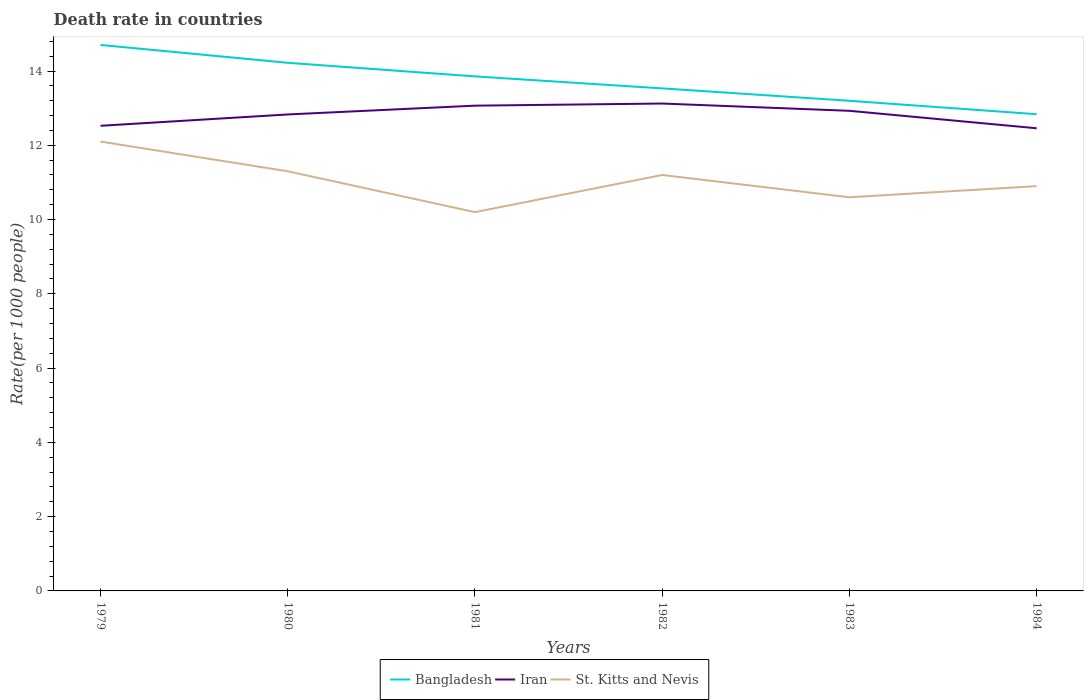How many different coloured lines are there?
Offer a terse response. 3. Across all years, what is the maximum death rate in Bangladesh?
Ensure brevity in your answer.  12.84. What is the total death rate in Bangladesh in the graph?
Provide a short and direct response. 0.66. What is the difference between the highest and the second highest death rate in St. Kitts and Nevis?
Give a very brief answer. 1.9. How many years are there in the graph?
Your response must be concise. 6. What is the difference between two consecutive major ticks on the Y-axis?
Keep it short and to the point. 2. Are the values on the major ticks of Y-axis written in scientific E-notation?
Give a very brief answer. No. Does the graph contain any zero values?
Provide a short and direct response. No. Does the graph contain grids?
Keep it short and to the point. No. Where does the legend appear in the graph?
Offer a terse response. Bottom center. How many legend labels are there?
Your answer should be compact. 3. How are the legend labels stacked?
Your response must be concise. Horizontal. What is the title of the graph?
Provide a short and direct response. Death rate in countries. Does "St. Martin (French part)" appear as one of the legend labels in the graph?
Give a very brief answer. No. What is the label or title of the Y-axis?
Provide a short and direct response. Rate(per 1000 people). What is the Rate(per 1000 people) in Bangladesh in 1979?
Your answer should be very brief. 14.7. What is the Rate(per 1000 people) in Iran in 1979?
Provide a succinct answer. 12.53. What is the Rate(per 1000 people) of St. Kitts and Nevis in 1979?
Your answer should be compact. 12.1. What is the Rate(per 1000 people) of Bangladesh in 1980?
Offer a terse response. 14.22. What is the Rate(per 1000 people) in Iran in 1980?
Keep it short and to the point. 12.83. What is the Rate(per 1000 people) of St. Kitts and Nevis in 1980?
Offer a terse response. 11.3. What is the Rate(per 1000 people) in Bangladesh in 1981?
Keep it short and to the point. 13.86. What is the Rate(per 1000 people) of Iran in 1981?
Your response must be concise. 13.07. What is the Rate(per 1000 people) in St. Kitts and Nevis in 1981?
Provide a succinct answer. 10.2. What is the Rate(per 1000 people) in Bangladesh in 1982?
Provide a succinct answer. 13.53. What is the Rate(per 1000 people) of Iran in 1982?
Give a very brief answer. 13.12. What is the Rate(per 1000 people) of St. Kitts and Nevis in 1982?
Keep it short and to the point. 11.2. What is the Rate(per 1000 people) in Bangladesh in 1983?
Your answer should be compact. 13.2. What is the Rate(per 1000 people) in Iran in 1983?
Keep it short and to the point. 12.93. What is the Rate(per 1000 people) of St. Kitts and Nevis in 1983?
Give a very brief answer. 10.6. What is the Rate(per 1000 people) of Bangladesh in 1984?
Provide a succinct answer. 12.84. What is the Rate(per 1000 people) in Iran in 1984?
Your response must be concise. 12.46. What is the Rate(per 1000 people) in St. Kitts and Nevis in 1984?
Your answer should be very brief. 10.9. Across all years, what is the maximum Rate(per 1000 people) of Bangladesh?
Make the answer very short. 14.7. Across all years, what is the maximum Rate(per 1000 people) in Iran?
Offer a terse response. 13.12. Across all years, what is the minimum Rate(per 1000 people) of Bangladesh?
Provide a short and direct response. 12.84. Across all years, what is the minimum Rate(per 1000 people) in Iran?
Give a very brief answer. 12.46. Across all years, what is the minimum Rate(per 1000 people) of St. Kitts and Nevis?
Offer a terse response. 10.2. What is the total Rate(per 1000 people) in Bangladesh in the graph?
Offer a terse response. 82.34. What is the total Rate(per 1000 people) in Iran in the graph?
Make the answer very short. 76.93. What is the total Rate(per 1000 people) of St. Kitts and Nevis in the graph?
Make the answer very short. 66.3. What is the difference between the Rate(per 1000 people) of Bangladesh in 1979 and that in 1980?
Provide a short and direct response. 0.48. What is the difference between the Rate(per 1000 people) in Iran in 1979 and that in 1980?
Give a very brief answer. -0.3. What is the difference between the Rate(per 1000 people) in St. Kitts and Nevis in 1979 and that in 1980?
Ensure brevity in your answer.  0.8. What is the difference between the Rate(per 1000 people) of Bangladesh in 1979 and that in 1981?
Your answer should be compact. 0.85. What is the difference between the Rate(per 1000 people) in Iran in 1979 and that in 1981?
Give a very brief answer. -0.54. What is the difference between the Rate(per 1000 people) in Bangladesh in 1979 and that in 1982?
Your answer should be compact. 1.17. What is the difference between the Rate(per 1000 people) in Iran in 1979 and that in 1982?
Make the answer very short. -0.6. What is the difference between the Rate(per 1000 people) of Bangladesh in 1979 and that in 1983?
Your answer should be compact. 1.5. What is the difference between the Rate(per 1000 people) in Iran in 1979 and that in 1983?
Provide a succinct answer. -0.4. What is the difference between the Rate(per 1000 people) of St. Kitts and Nevis in 1979 and that in 1983?
Offer a terse response. 1.5. What is the difference between the Rate(per 1000 people) of Bangladesh in 1979 and that in 1984?
Give a very brief answer. 1.86. What is the difference between the Rate(per 1000 people) of Iran in 1979 and that in 1984?
Ensure brevity in your answer.  0.07. What is the difference between the Rate(per 1000 people) in St. Kitts and Nevis in 1979 and that in 1984?
Provide a succinct answer. 1.2. What is the difference between the Rate(per 1000 people) of Bangladesh in 1980 and that in 1981?
Your answer should be very brief. 0.37. What is the difference between the Rate(per 1000 people) of Iran in 1980 and that in 1981?
Give a very brief answer. -0.24. What is the difference between the Rate(per 1000 people) in Bangladesh in 1980 and that in 1982?
Offer a very short reply. 0.69. What is the difference between the Rate(per 1000 people) in Iran in 1980 and that in 1982?
Make the answer very short. -0.29. What is the difference between the Rate(per 1000 people) of St. Kitts and Nevis in 1980 and that in 1982?
Your answer should be very brief. 0.1. What is the difference between the Rate(per 1000 people) of Bangladesh in 1980 and that in 1983?
Keep it short and to the point. 1.02. What is the difference between the Rate(per 1000 people) in Iran in 1980 and that in 1983?
Give a very brief answer. -0.1. What is the difference between the Rate(per 1000 people) of Bangladesh in 1980 and that in 1984?
Your response must be concise. 1.38. What is the difference between the Rate(per 1000 people) of Iran in 1980 and that in 1984?
Ensure brevity in your answer.  0.37. What is the difference between the Rate(per 1000 people) of St. Kitts and Nevis in 1980 and that in 1984?
Offer a very short reply. 0.4. What is the difference between the Rate(per 1000 people) of Bangladesh in 1981 and that in 1982?
Ensure brevity in your answer.  0.32. What is the difference between the Rate(per 1000 people) in Iran in 1981 and that in 1982?
Your response must be concise. -0.06. What is the difference between the Rate(per 1000 people) of Bangladesh in 1981 and that in 1983?
Give a very brief answer. 0.66. What is the difference between the Rate(per 1000 people) in Iran in 1981 and that in 1983?
Your answer should be very brief. 0.14. What is the difference between the Rate(per 1000 people) of Bangladesh in 1981 and that in 1984?
Keep it short and to the point. 1.02. What is the difference between the Rate(per 1000 people) in Iran in 1981 and that in 1984?
Ensure brevity in your answer.  0.61. What is the difference between the Rate(per 1000 people) in St. Kitts and Nevis in 1981 and that in 1984?
Give a very brief answer. -0.7. What is the difference between the Rate(per 1000 people) of Bangladesh in 1982 and that in 1983?
Offer a very short reply. 0.33. What is the difference between the Rate(per 1000 people) of Iran in 1982 and that in 1983?
Your answer should be very brief. 0.2. What is the difference between the Rate(per 1000 people) in Bangladesh in 1982 and that in 1984?
Offer a very short reply. 0.69. What is the difference between the Rate(per 1000 people) of Iran in 1982 and that in 1984?
Your response must be concise. 0.67. What is the difference between the Rate(per 1000 people) in St. Kitts and Nevis in 1982 and that in 1984?
Give a very brief answer. 0.3. What is the difference between the Rate(per 1000 people) of Bangladesh in 1983 and that in 1984?
Provide a short and direct response. 0.36. What is the difference between the Rate(per 1000 people) of Iran in 1983 and that in 1984?
Your answer should be very brief. 0.47. What is the difference between the Rate(per 1000 people) of St. Kitts and Nevis in 1983 and that in 1984?
Ensure brevity in your answer.  -0.3. What is the difference between the Rate(per 1000 people) in Bangladesh in 1979 and the Rate(per 1000 people) in Iran in 1980?
Give a very brief answer. 1.87. What is the difference between the Rate(per 1000 people) of Bangladesh in 1979 and the Rate(per 1000 people) of St. Kitts and Nevis in 1980?
Provide a short and direct response. 3.4. What is the difference between the Rate(per 1000 people) in Iran in 1979 and the Rate(per 1000 people) in St. Kitts and Nevis in 1980?
Provide a short and direct response. 1.23. What is the difference between the Rate(per 1000 people) in Bangladesh in 1979 and the Rate(per 1000 people) in Iran in 1981?
Keep it short and to the point. 1.64. What is the difference between the Rate(per 1000 people) in Bangladesh in 1979 and the Rate(per 1000 people) in St. Kitts and Nevis in 1981?
Ensure brevity in your answer.  4.5. What is the difference between the Rate(per 1000 people) of Iran in 1979 and the Rate(per 1000 people) of St. Kitts and Nevis in 1981?
Provide a succinct answer. 2.33. What is the difference between the Rate(per 1000 people) of Bangladesh in 1979 and the Rate(per 1000 people) of Iran in 1982?
Provide a short and direct response. 1.58. What is the difference between the Rate(per 1000 people) in Bangladesh in 1979 and the Rate(per 1000 people) in St. Kitts and Nevis in 1982?
Offer a very short reply. 3.5. What is the difference between the Rate(per 1000 people) in Iran in 1979 and the Rate(per 1000 people) in St. Kitts and Nevis in 1982?
Offer a terse response. 1.32. What is the difference between the Rate(per 1000 people) of Bangladesh in 1979 and the Rate(per 1000 people) of Iran in 1983?
Keep it short and to the point. 1.77. What is the difference between the Rate(per 1000 people) in Bangladesh in 1979 and the Rate(per 1000 people) in St. Kitts and Nevis in 1983?
Offer a terse response. 4.1. What is the difference between the Rate(per 1000 people) of Iran in 1979 and the Rate(per 1000 people) of St. Kitts and Nevis in 1983?
Provide a short and direct response. 1.93. What is the difference between the Rate(per 1000 people) of Bangladesh in 1979 and the Rate(per 1000 people) of Iran in 1984?
Make the answer very short. 2.24. What is the difference between the Rate(per 1000 people) in Bangladesh in 1979 and the Rate(per 1000 people) in St. Kitts and Nevis in 1984?
Keep it short and to the point. 3.8. What is the difference between the Rate(per 1000 people) in Iran in 1979 and the Rate(per 1000 people) in St. Kitts and Nevis in 1984?
Offer a very short reply. 1.62. What is the difference between the Rate(per 1000 people) in Bangladesh in 1980 and the Rate(per 1000 people) in Iran in 1981?
Offer a very short reply. 1.15. What is the difference between the Rate(per 1000 people) of Bangladesh in 1980 and the Rate(per 1000 people) of St. Kitts and Nevis in 1981?
Your answer should be very brief. 4.02. What is the difference between the Rate(per 1000 people) in Iran in 1980 and the Rate(per 1000 people) in St. Kitts and Nevis in 1981?
Your answer should be very brief. 2.63. What is the difference between the Rate(per 1000 people) in Bangladesh in 1980 and the Rate(per 1000 people) in Iran in 1982?
Offer a terse response. 1.1. What is the difference between the Rate(per 1000 people) of Bangladesh in 1980 and the Rate(per 1000 people) of St. Kitts and Nevis in 1982?
Your answer should be very brief. 3.02. What is the difference between the Rate(per 1000 people) of Iran in 1980 and the Rate(per 1000 people) of St. Kitts and Nevis in 1982?
Ensure brevity in your answer.  1.63. What is the difference between the Rate(per 1000 people) of Bangladesh in 1980 and the Rate(per 1000 people) of Iran in 1983?
Offer a very short reply. 1.29. What is the difference between the Rate(per 1000 people) in Bangladesh in 1980 and the Rate(per 1000 people) in St. Kitts and Nevis in 1983?
Give a very brief answer. 3.62. What is the difference between the Rate(per 1000 people) in Iran in 1980 and the Rate(per 1000 people) in St. Kitts and Nevis in 1983?
Ensure brevity in your answer.  2.23. What is the difference between the Rate(per 1000 people) in Bangladesh in 1980 and the Rate(per 1000 people) in Iran in 1984?
Your answer should be very brief. 1.76. What is the difference between the Rate(per 1000 people) in Bangladesh in 1980 and the Rate(per 1000 people) in St. Kitts and Nevis in 1984?
Keep it short and to the point. 3.32. What is the difference between the Rate(per 1000 people) of Iran in 1980 and the Rate(per 1000 people) of St. Kitts and Nevis in 1984?
Provide a succinct answer. 1.93. What is the difference between the Rate(per 1000 people) in Bangladesh in 1981 and the Rate(per 1000 people) in Iran in 1982?
Offer a terse response. 0.73. What is the difference between the Rate(per 1000 people) of Bangladesh in 1981 and the Rate(per 1000 people) of St. Kitts and Nevis in 1982?
Provide a short and direct response. 2.65. What is the difference between the Rate(per 1000 people) in Iran in 1981 and the Rate(per 1000 people) in St. Kitts and Nevis in 1982?
Your answer should be compact. 1.87. What is the difference between the Rate(per 1000 people) of Bangladesh in 1981 and the Rate(per 1000 people) of Iran in 1983?
Offer a very short reply. 0.93. What is the difference between the Rate(per 1000 people) of Bangladesh in 1981 and the Rate(per 1000 people) of St. Kitts and Nevis in 1983?
Provide a short and direct response. 3.25. What is the difference between the Rate(per 1000 people) of Iran in 1981 and the Rate(per 1000 people) of St. Kitts and Nevis in 1983?
Make the answer very short. 2.47. What is the difference between the Rate(per 1000 people) in Bangladesh in 1981 and the Rate(per 1000 people) in Iran in 1984?
Offer a terse response. 1.4. What is the difference between the Rate(per 1000 people) of Bangladesh in 1981 and the Rate(per 1000 people) of St. Kitts and Nevis in 1984?
Provide a short and direct response. 2.96. What is the difference between the Rate(per 1000 people) in Iran in 1981 and the Rate(per 1000 people) in St. Kitts and Nevis in 1984?
Ensure brevity in your answer.  2.17. What is the difference between the Rate(per 1000 people) of Bangladesh in 1982 and the Rate(per 1000 people) of Iran in 1983?
Your answer should be compact. 0.6. What is the difference between the Rate(per 1000 people) in Bangladesh in 1982 and the Rate(per 1000 people) in St. Kitts and Nevis in 1983?
Your response must be concise. 2.93. What is the difference between the Rate(per 1000 people) in Iran in 1982 and the Rate(per 1000 people) in St. Kitts and Nevis in 1983?
Provide a succinct answer. 2.52. What is the difference between the Rate(per 1000 people) of Bangladesh in 1982 and the Rate(per 1000 people) of Iran in 1984?
Make the answer very short. 1.07. What is the difference between the Rate(per 1000 people) in Bangladesh in 1982 and the Rate(per 1000 people) in St. Kitts and Nevis in 1984?
Your response must be concise. 2.63. What is the difference between the Rate(per 1000 people) of Iran in 1982 and the Rate(per 1000 people) of St. Kitts and Nevis in 1984?
Your response must be concise. 2.22. What is the difference between the Rate(per 1000 people) in Bangladesh in 1983 and the Rate(per 1000 people) in Iran in 1984?
Your answer should be very brief. 0.74. What is the difference between the Rate(per 1000 people) of Bangladesh in 1983 and the Rate(per 1000 people) of St. Kitts and Nevis in 1984?
Give a very brief answer. 2.3. What is the difference between the Rate(per 1000 people) in Iran in 1983 and the Rate(per 1000 people) in St. Kitts and Nevis in 1984?
Give a very brief answer. 2.03. What is the average Rate(per 1000 people) of Bangladesh per year?
Keep it short and to the point. 13.72. What is the average Rate(per 1000 people) in Iran per year?
Ensure brevity in your answer.  12.82. What is the average Rate(per 1000 people) of St. Kitts and Nevis per year?
Ensure brevity in your answer.  11.05. In the year 1979, what is the difference between the Rate(per 1000 people) in Bangladesh and Rate(per 1000 people) in Iran?
Provide a short and direct response. 2.18. In the year 1979, what is the difference between the Rate(per 1000 people) in Bangladesh and Rate(per 1000 people) in St. Kitts and Nevis?
Give a very brief answer. 2.6. In the year 1979, what is the difference between the Rate(per 1000 people) in Iran and Rate(per 1000 people) in St. Kitts and Nevis?
Your response must be concise. 0.42. In the year 1980, what is the difference between the Rate(per 1000 people) of Bangladesh and Rate(per 1000 people) of Iran?
Offer a very short reply. 1.39. In the year 1980, what is the difference between the Rate(per 1000 people) of Bangladesh and Rate(per 1000 people) of St. Kitts and Nevis?
Ensure brevity in your answer.  2.92. In the year 1980, what is the difference between the Rate(per 1000 people) of Iran and Rate(per 1000 people) of St. Kitts and Nevis?
Keep it short and to the point. 1.53. In the year 1981, what is the difference between the Rate(per 1000 people) of Bangladesh and Rate(per 1000 people) of Iran?
Provide a short and direct response. 0.79. In the year 1981, what is the difference between the Rate(per 1000 people) of Bangladesh and Rate(per 1000 people) of St. Kitts and Nevis?
Your response must be concise. 3.65. In the year 1981, what is the difference between the Rate(per 1000 people) of Iran and Rate(per 1000 people) of St. Kitts and Nevis?
Your response must be concise. 2.87. In the year 1982, what is the difference between the Rate(per 1000 people) in Bangladesh and Rate(per 1000 people) in Iran?
Make the answer very short. 0.41. In the year 1982, what is the difference between the Rate(per 1000 people) of Bangladesh and Rate(per 1000 people) of St. Kitts and Nevis?
Your answer should be compact. 2.33. In the year 1982, what is the difference between the Rate(per 1000 people) in Iran and Rate(per 1000 people) in St. Kitts and Nevis?
Your answer should be very brief. 1.92. In the year 1983, what is the difference between the Rate(per 1000 people) of Bangladesh and Rate(per 1000 people) of Iran?
Give a very brief answer. 0.27. In the year 1983, what is the difference between the Rate(per 1000 people) of Bangladesh and Rate(per 1000 people) of St. Kitts and Nevis?
Your answer should be very brief. 2.6. In the year 1983, what is the difference between the Rate(per 1000 people) of Iran and Rate(per 1000 people) of St. Kitts and Nevis?
Keep it short and to the point. 2.33. In the year 1984, what is the difference between the Rate(per 1000 people) of Bangladesh and Rate(per 1000 people) of Iran?
Your answer should be compact. 0.38. In the year 1984, what is the difference between the Rate(per 1000 people) in Bangladesh and Rate(per 1000 people) in St. Kitts and Nevis?
Provide a short and direct response. 1.94. In the year 1984, what is the difference between the Rate(per 1000 people) in Iran and Rate(per 1000 people) in St. Kitts and Nevis?
Your answer should be very brief. 1.56. What is the ratio of the Rate(per 1000 people) in Bangladesh in 1979 to that in 1980?
Your answer should be very brief. 1.03. What is the ratio of the Rate(per 1000 people) of Iran in 1979 to that in 1980?
Keep it short and to the point. 0.98. What is the ratio of the Rate(per 1000 people) of St. Kitts and Nevis in 1979 to that in 1980?
Offer a terse response. 1.07. What is the ratio of the Rate(per 1000 people) of Bangladesh in 1979 to that in 1981?
Provide a succinct answer. 1.06. What is the ratio of the Rate(per 1000 people) of Iran in 1979 to that in 1981?
Make the answer very short. 0.96. What is the ratio of the Rate(per 1000 people) in St. Kitts and Nevis in 1979 to that in 1981?
Make the answer very short. 1.19. What is the ratio of the Rate(per 1000 people) of Bangladesh in 1979 to that in 1982?
Keep it short and to the point. 1.09. What is the ratio of the Rate(per 1000 people) in Iran in 1979 to that in 1982?
Offer a very short reply. 0.95. What is the ratio of the Rate(per 1000 people) of St. Kitts and Nevis in 1979 to that in 1982?
Ensure brevity in your answer.  1.08. What is the ratio of the Rate(per 1000 people) of Bangladesh in 1979 to that in 1983?
Provide a succinct answer. 1.11. What is the ratio of the Rate(per 1000 people) of Iran in 1979 to that in 1983?
Give a very brief answer. 0.97. What is the ratio of the Rate(per 1000 people) of St. Kitts and Nevis in 1979 to that in 1983?
Your response must be concise. 1.14. What is the ratio of the Rate(per 1000 people) of Bangladesh in 1979 to that in 1984?
Give a very brief answer. 1.15. What is the ratio of the Rate(per 1000 people) in Iran in 1979 to that in 1984?
Provide a short and direct response. 1.01. What is the ratio of the Rate(per 1000 people) of St. Kitts and Nevis in 1979 to that in 1984?
Your response must be concise. 1.11. What is the ratio of the Rate(per 1000 people) of Bangladesh in 1980 to that in 1981?
Offer a very short reply. 1.03. What is the ratio of the Rate(per 1000 people) in Iran in 1980 to that in 1981?
Keep it short and to the point. 0.98. What is the ratio of the Rate(per 1000 people) in St. Kitts and Nevis in 1980 to that in 1981?
Offer a very short reply. 1.11. What is the ratio of the Rate(per 1000 people) in Bangladesh in 1980 to that in 1982?
Your answer should be very brief. 1.05. What is the ratio of the Rate(per 1000 people) of Iran in 1980 to that in 1982?
Give a very brief answer. 0.98. What is the ratio of the Rate(per 1000 people) of St. Kitts and Nevis in 1980 to that in 1982?
Your response must be concise. 1.01. What is the ratio of the Rate(per 1000 people) of Bangladesh in 1980 to that in 1983?
Ensure brevity in your answer.  1.08. What is the ratio of the Rate(per 1000 people) in Iran in 1980 to that in 1983?
Provide a succinct answer. 0.99. What is the ratio of the Rate(per 1000 people) of St. Kitts and Nevis in 1980 to that in 1983?
Give a very brief answer. 1.07. What is the ratio of the Rate(per 1000 people) in Bangladesh in 1980 to that in 1984?
Make the answer very short. 1.11. What is the ratio of the Rate(per 1000 people) of Iran in 1980 to that in 1984?
Keep it short and to the point. 1.03. What is the ratio of the Rate(per 1000 people) in St. Kitts and Nevis in 1980 to that in 1984?
Ensure brevity in your answer.  1.04. What is the ratio of the Rate(per 1000 people) of Bangladesh in 1981 to that in 1982?
Offer a very short reply. 1.02. What is the ratio of the Rate(per 1000 people) in Iran in 1981 to that in 1982?
Offer a terse response. 1. What is the ratio of the Rate(per 1000 people) of St. Kitts and Nevis in 1981 to that in 1982?
Your response must be concise. 0.91. What is the ratio of the Rate(per 1000 people) of Bangladesh in 1981 to that in 1983?
Your answer should be compact. 1.05. What is the ratio of the Rate(per 1000 people) of Iran in 1981 to that in 1983?
Your answer should be compact. 1.01. What is the ratio of the Rate(per 1000 people) of St. Kitts and Nevis in 1981 to that in 1983?
Your answer should be very brief. 0.96. What is the ratio of the Rate(per 1000 people) of Bangladesh in 1981 to that in 1984?
Offer a very short reply. 1.08. What is the ratio of the Rate(per 1000 people) of Iran in 1981 to that in 1984?
Make the answer very short. 1.05. What is the ratio of the Rate(per 1000 people) in St. Kitts and Nevis in 1981 to that in 1984?
Give a very brief answer. 0.94. What is the ratio of the Rate(per 1000 people) of Bangladesh in 1982 to that in 1983?
Your answer should be very brief. 1.03. What is the ratio of the Rate(per 1000 people) of Iran in 1982 to that in 1983?
Offer a very short reply. 1.02. What is the ratio of the Rate(per 1000 people) in St. Kitts and Nevis in 1982 to that in 1983?
Offer a terse response. 1.06. What is the ratio of the Rate(per 1000 people) of Bangladesh in 1982 to that in 1984?
Offer a terse response. 1.05. What is the ratio of the Rate(per 1000 people) in Iran in 1982 to that in 1984?
Offer a very short reply. 1.05. What is the ratio of the Rate(per 1000 people) of St. Kitts and Nevis in 1982 to that in 1984?
Your response must be concise. 1.03. What is the ratio of the Rate(per 1000 people) of Bangladesh in 1983 to that in 1984?
Ensure brevity in your answer.  1.03. What is the ratio of the Rate(per 1000 people) of Iran in 1983 to that in 1984?
Your answer should be compact. 1.04. What is the ratio of the Rate(per 1000 people) of St. Kitts and Nevis in 1983 to that in 1984?
Offer a terse response. 0.97. What is the difference between the highest and the second highest Rate(per 1000 people) of Bangladesh?
Provide a succinct answer. 0.48. What is the difference between the highest and the second highest Rate(per 1000 people) of Iran?
Make the answer very short. 0.06. What is the difference between the highest and the lowest Rate(per 1000 people) in Bangladesh?
Provide a succinct answer. 1.86. What is the difference between the highest and the lowest Rate(per 1000 people) in Iran?
Ensure brevity in your answer.  0.67. What is the difference between the highest and the lowest Rate(per 1000 people) of St. Kitts and Nevis?
Offer a terse response. 1.9. 